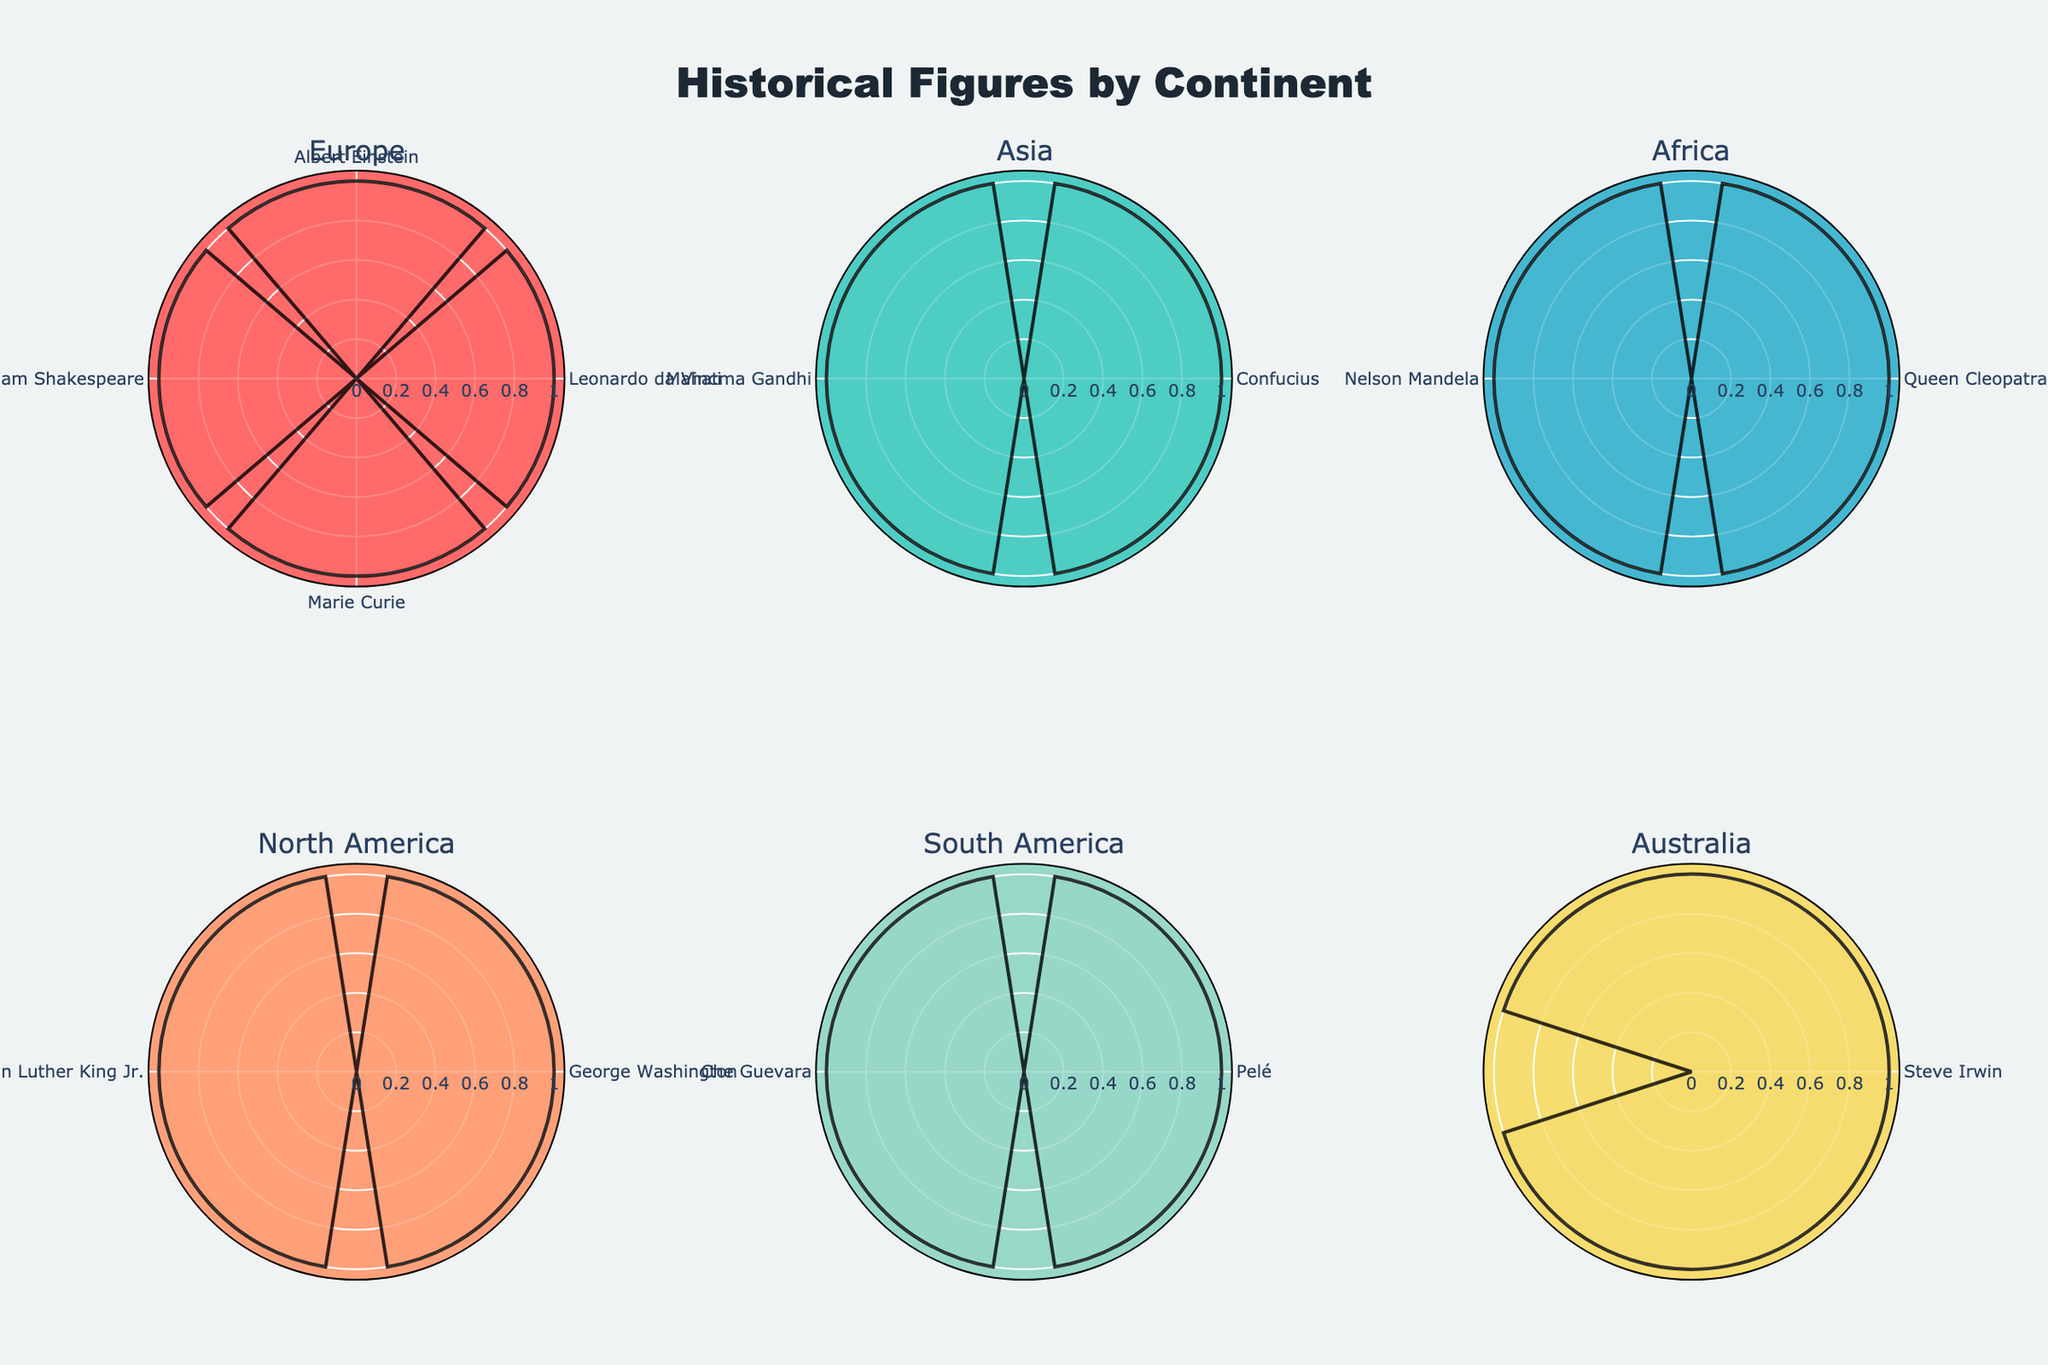What is the title of the figure? The title is the main text at the top of the visual, usually summarizing the content of the plot. Here, it reads "Historical Figures by Continent".
Answer: Historical Figures by Continent How many subplots are present in the figure? The figure contains a grid of subplots. Upon counting them, there are 2 rows and 3 columns, giving a total of 6 subplots.
Answer: 6 Which continent has the most historical figures represented? By looking at the length of the bars within each subplot, Europe has the most figures, shown by the multiple bars in the Europe section.
Answer: Europe How many historical figures are from North America? In the North America subplot, there are two bars, corresponding to the historical figures George Washington and Martin Luther King Jr.
Answer: 2 Which continent includes figures like Cleopatra and Nelson Mandela? Referring to the labels in the subplots, Cleopatra and Nelson Mandela are found in the subplot labeled "Africa".
Answer: Africa What colors are used to represent Europe and Asia in the figure? Each subplot uses a distinct color. Europe is represented with a dark coral-like color, and Asia with a sea-green to greenish-blue color.
Answer: Europe: Dark coral-like, Asia: Sea-green How many continents have only one historical figure? Examining each subplot, South America and Australia are the only ones with a single bar each.
Answer: 2 Compare the number of historical figures from Asia and Africa. Which has more? Asia has figures like Confucius and Mahatma Gandhi (total of 2), while Africa has Cleopatra and Nelson Mandela (total of 2), so they are equal.
Answer: Equal Which continent features Steve Irwin? By checking the labels within the subplots, Steve Irwin is found under the continent labeled "Australia".
Answer: Australia How does the number of historical figures from Europe compare to that from South America? By counting the bars, Europe has 5 historical figures, whereas South America has only 2. Thus, Europe has more figures.
Answer: Europe has more 